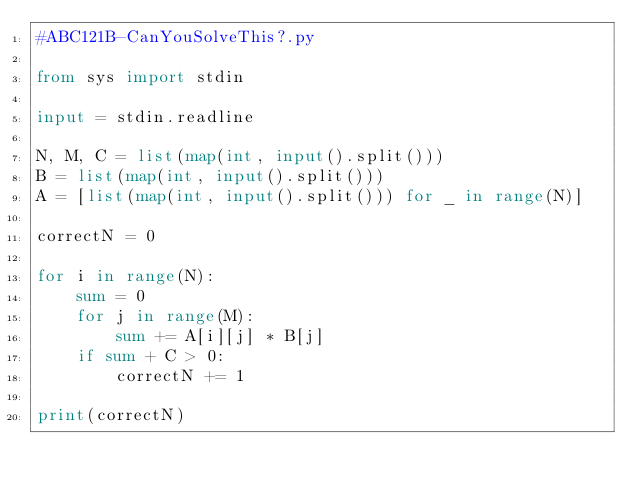Convert code to text. <code><loc_0><loc_0><loc_500><loc_500><_Python_>#ABC121B-CanYouSolveThis?.py

from sys import stdin

input = stdin.readline

N, M, C = list(map(int, input().split()))
B = list(map(int, input().split()))
A = [list(map(int, input().split())) for _ in range(N)]

correctN = 0

for i in range(N):
    sum = 0
    for j in range(M):
        sum += A[i][j] * B[j]
    if sum + C > 0:
        correctN += 1

print(correctN)
</code> 